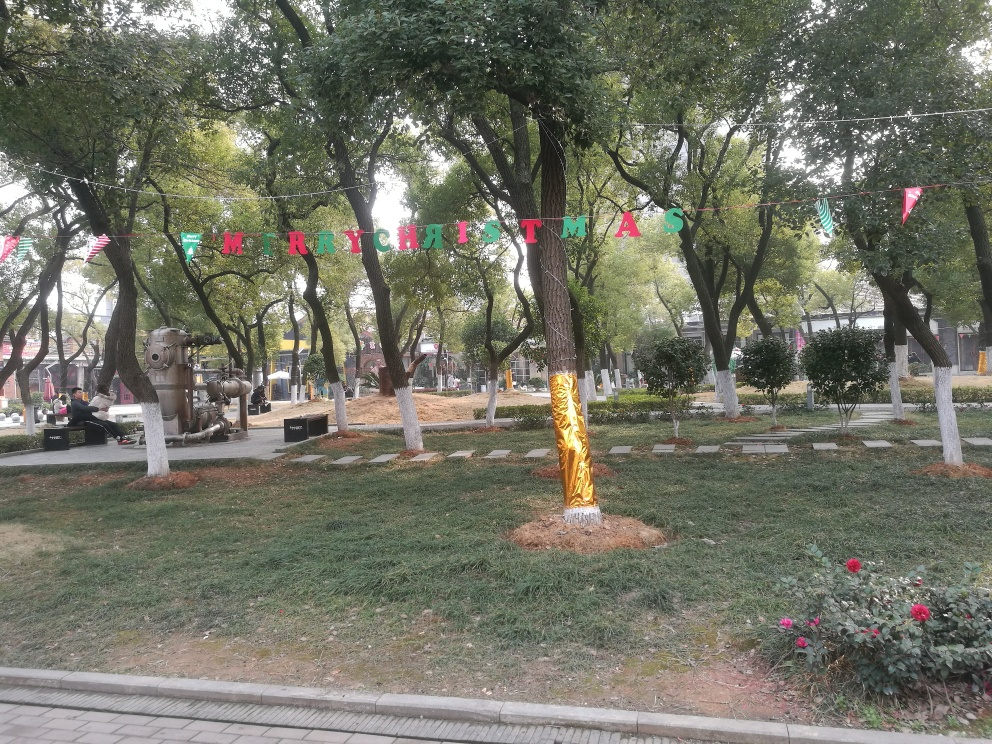Can you describe the decorations seen in the park? Sure, the park is adorned with festive decorations. There’s a 'MERRY CHRISTMAS' banner with individual letters on colorful pennants hung between the trees. One tree stands out with its trunk wrapped in shiny golden material, adding a touch of sparkle to the surroundings. 